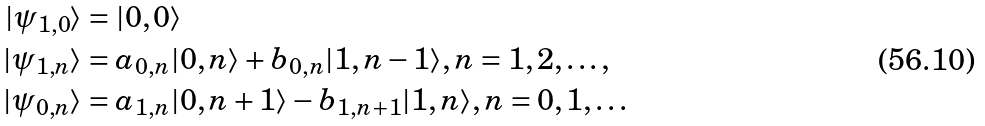Convert formula to latex. <formula><loc_0><loc_0><loc_500><loc_500>| \psi _ { 1 , 0 } \rangle & = | 0 , 0 \rangle \\ | \psi _ { 1 , n } \rangle & = a _ { 0 , n } | 0 , n \rangle + b _ { 0 , n } | 1 , n - 1 \rangle , n = 1 , 2 , \dots , \\ | \psi _ { 0 , n } \rangle & = a _ { 1 , n } | 0 , n + 1 \rangle - b _ { 1 , n + 1 } | 1 , n \rangle , n = 0 , 1 , \dots</formula> 